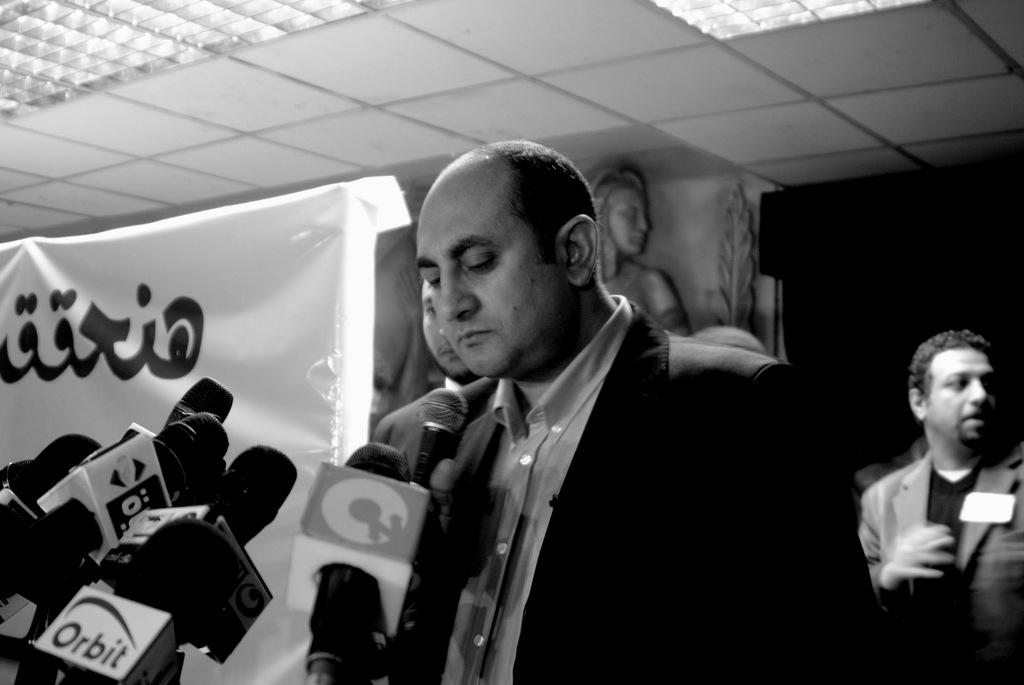What is the main subject of the image? There are miles in the image. Can you describe the person in the image? There is a person standing in the image. How many other people can be seen in the image? There are two persons standing in the background of the image. What can be seen in the background of the image? There is a banner, sculptures, lights, a ceiling, and a wall in the background of the image. What type of letters can be seen written on the cloth in the image? There is no cloth or letters present in the image. 